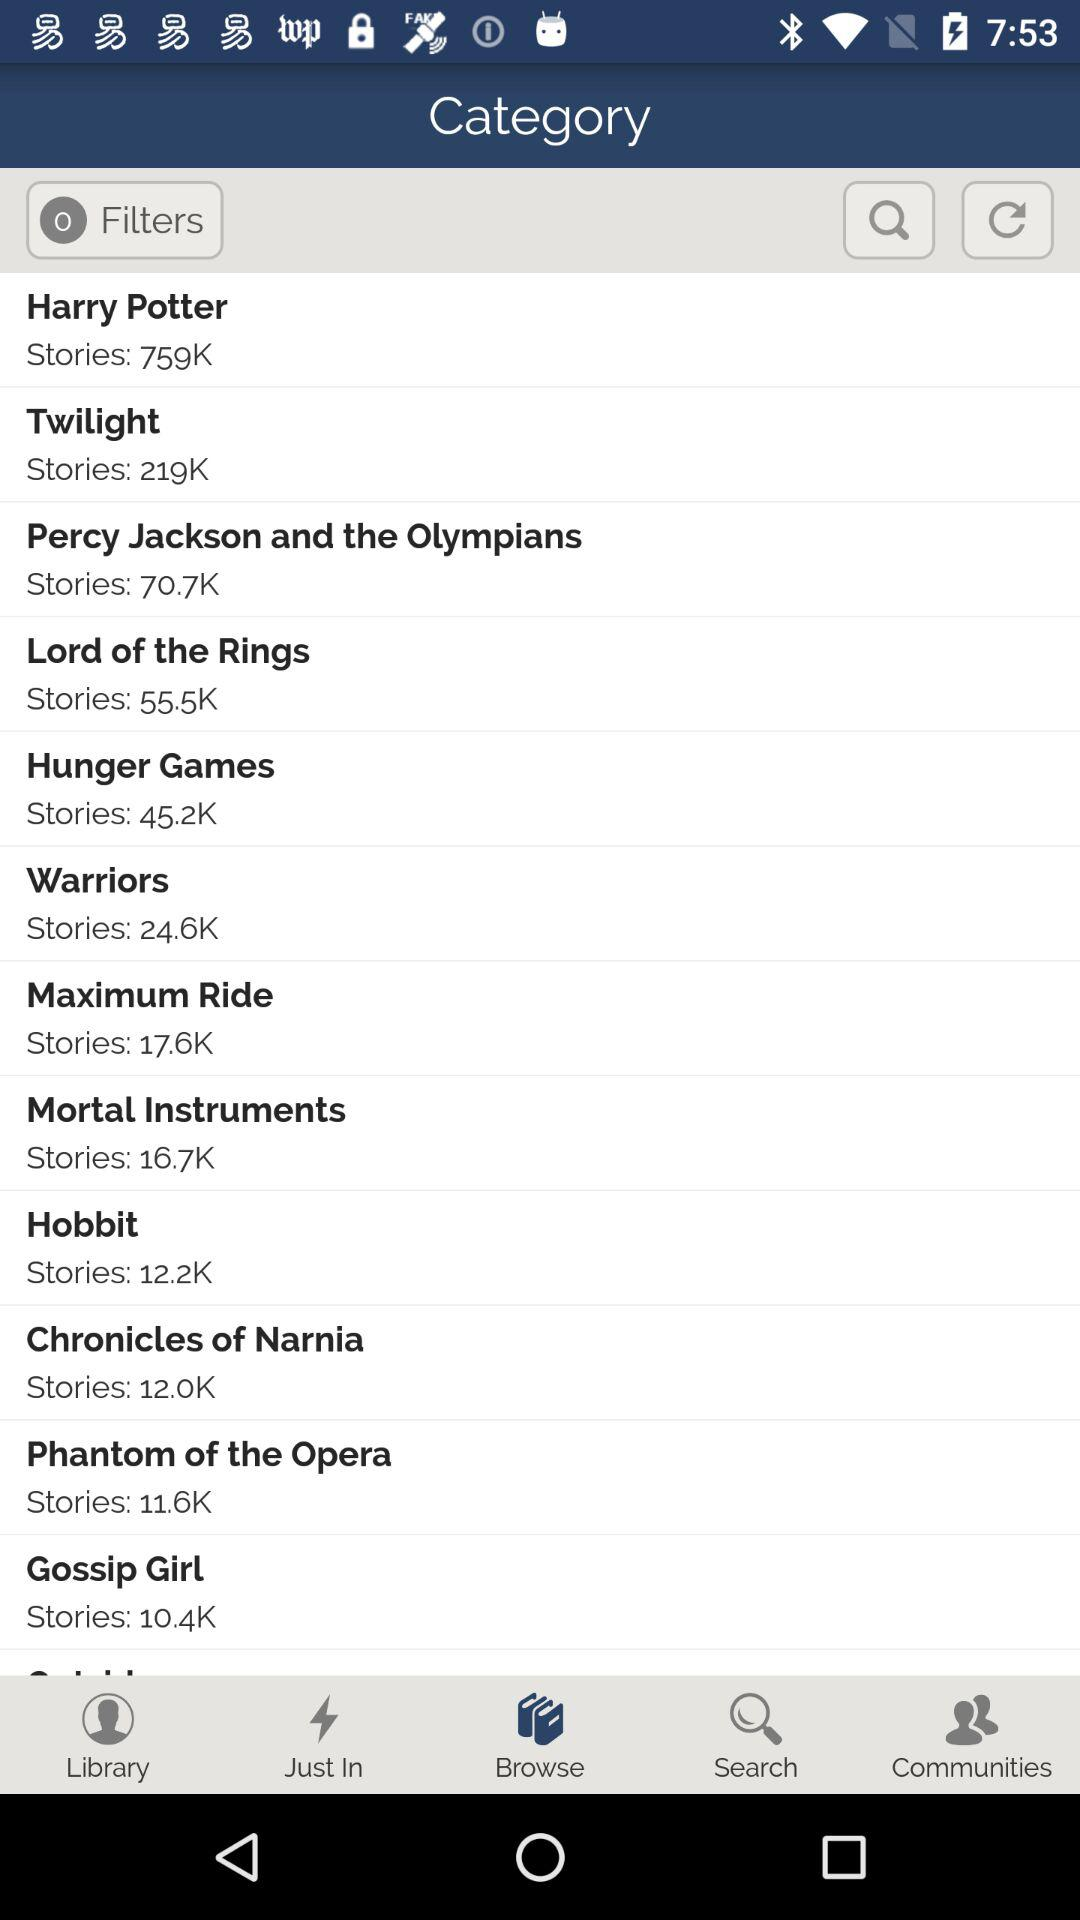How many stories does the series with the highest number of stories have?
Answer the question using a single word or phrase. 759K 